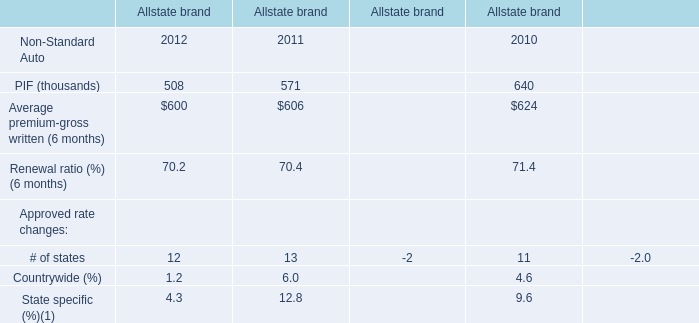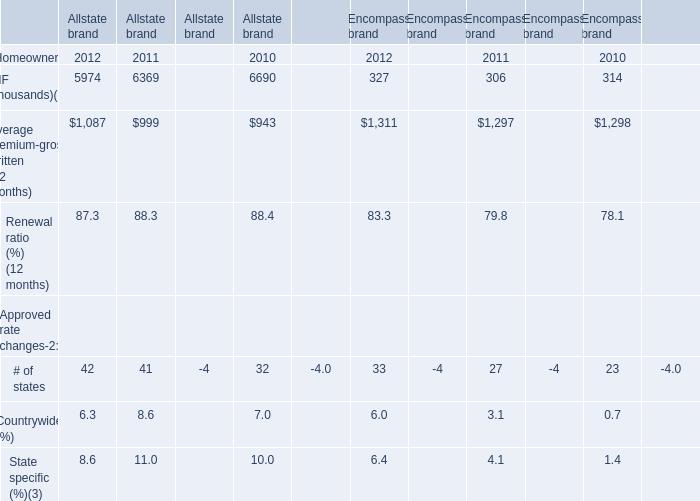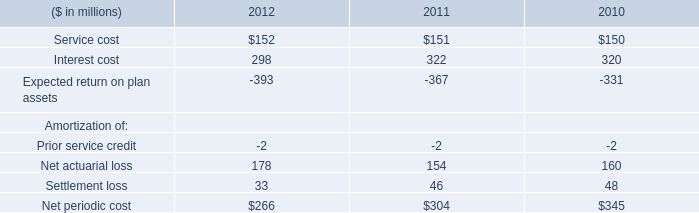What's the 2012 increasing rate of Average premium-gross written (12 months) of Allstate brand? 
Computations: ((1087 - 999) / 999)
Answer: 0.08809. 